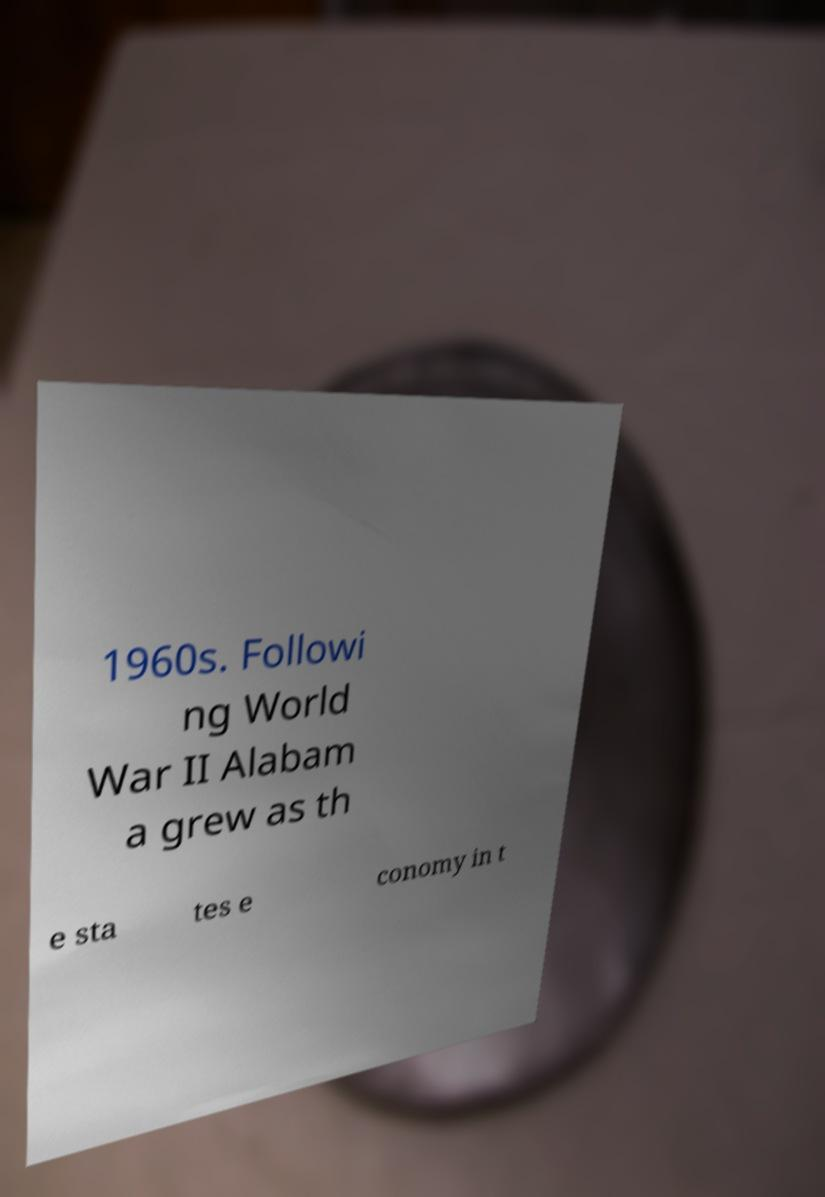I need the written content from this picture converted into text. Can you do that? 1960s. Followi ng World War II Alabam a grew as th e sta tes e conomy in t 